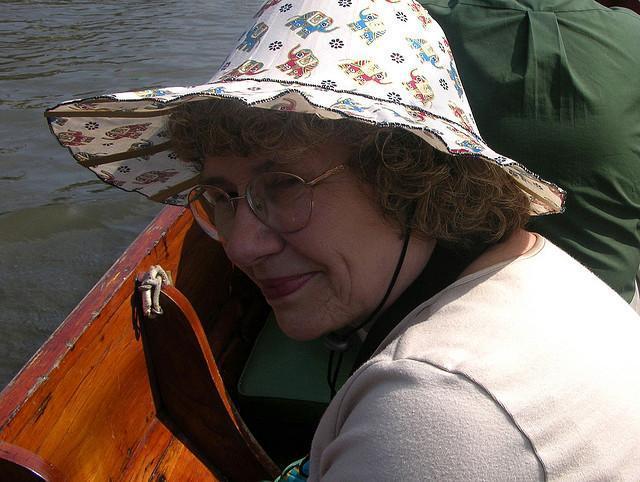How many people are there?
Give a very brief answer. 2. How many cars are in front of the motorcycle?
Give a very brief answer. 0. 